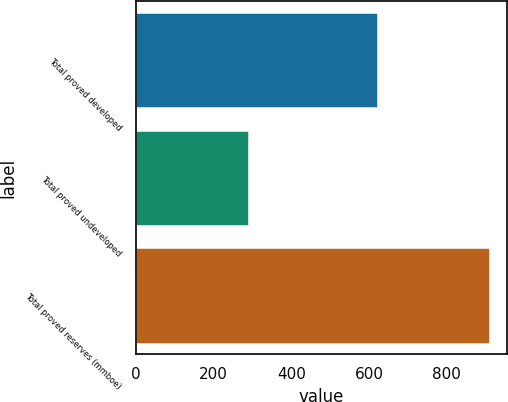Convert chart to OTSL. <chart><loc_0><loc_0><loc_500><loc_500><bar_chart><fcel>Total proved developed<fcel>Total proved undeveloped<fcel>Total proved reserves (mmboe)<nl><fcel>621<fcel>289<fcel>910<nl></chart> 